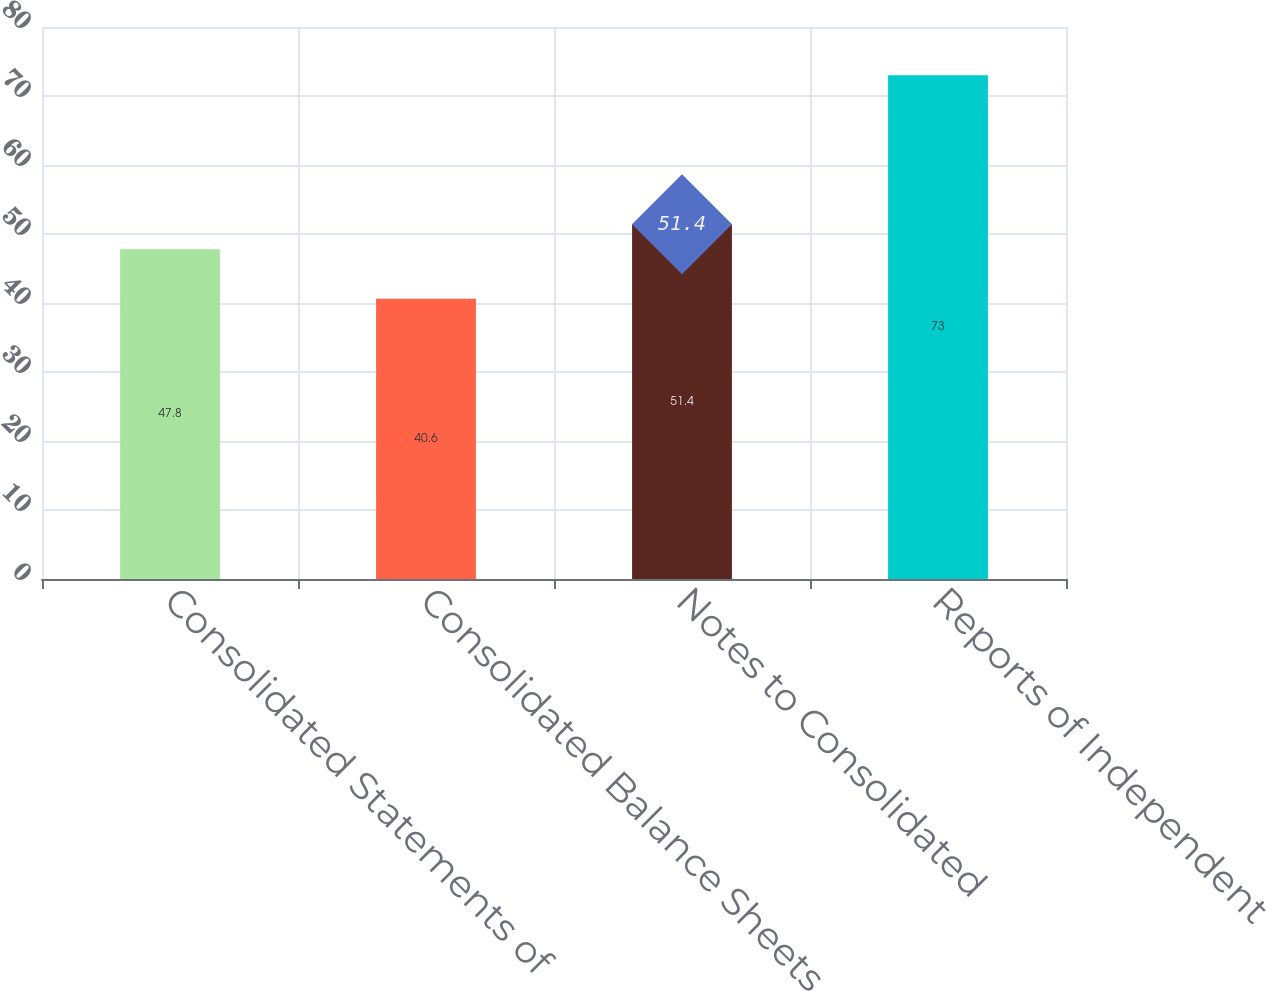Convert chart to OTSL. <chart><loc_0><loc_0><loc_500><loc_500><bar_chart><fcel>Consolidated Statements of<fcel>Consolidated Balance Sheets<fcel>Notes to Consolidated<fcel>Reports of Independent<nl><fcel>47.8<fcel>40.6<fcel>51.4<fcel>73<nl></chart> 